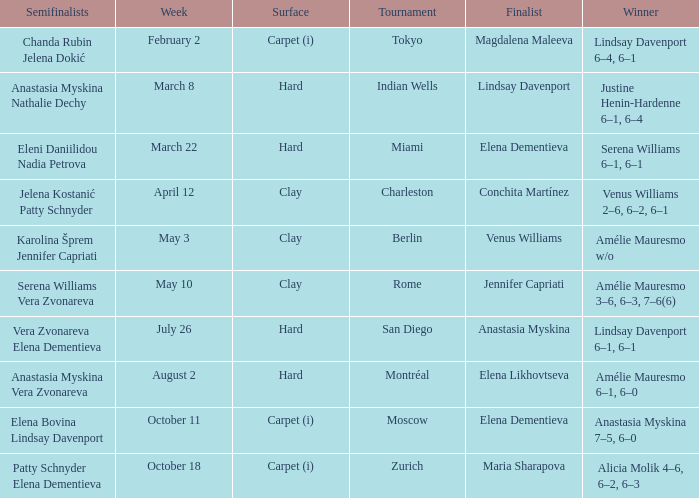Who was the finalist of the hard surface tournament in Miami? Elena Dementieva. 